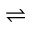Convert formula to latex. <formula><loc_0><loc_0><loc_500><loc_500>\rightleftharpoons</formula> 